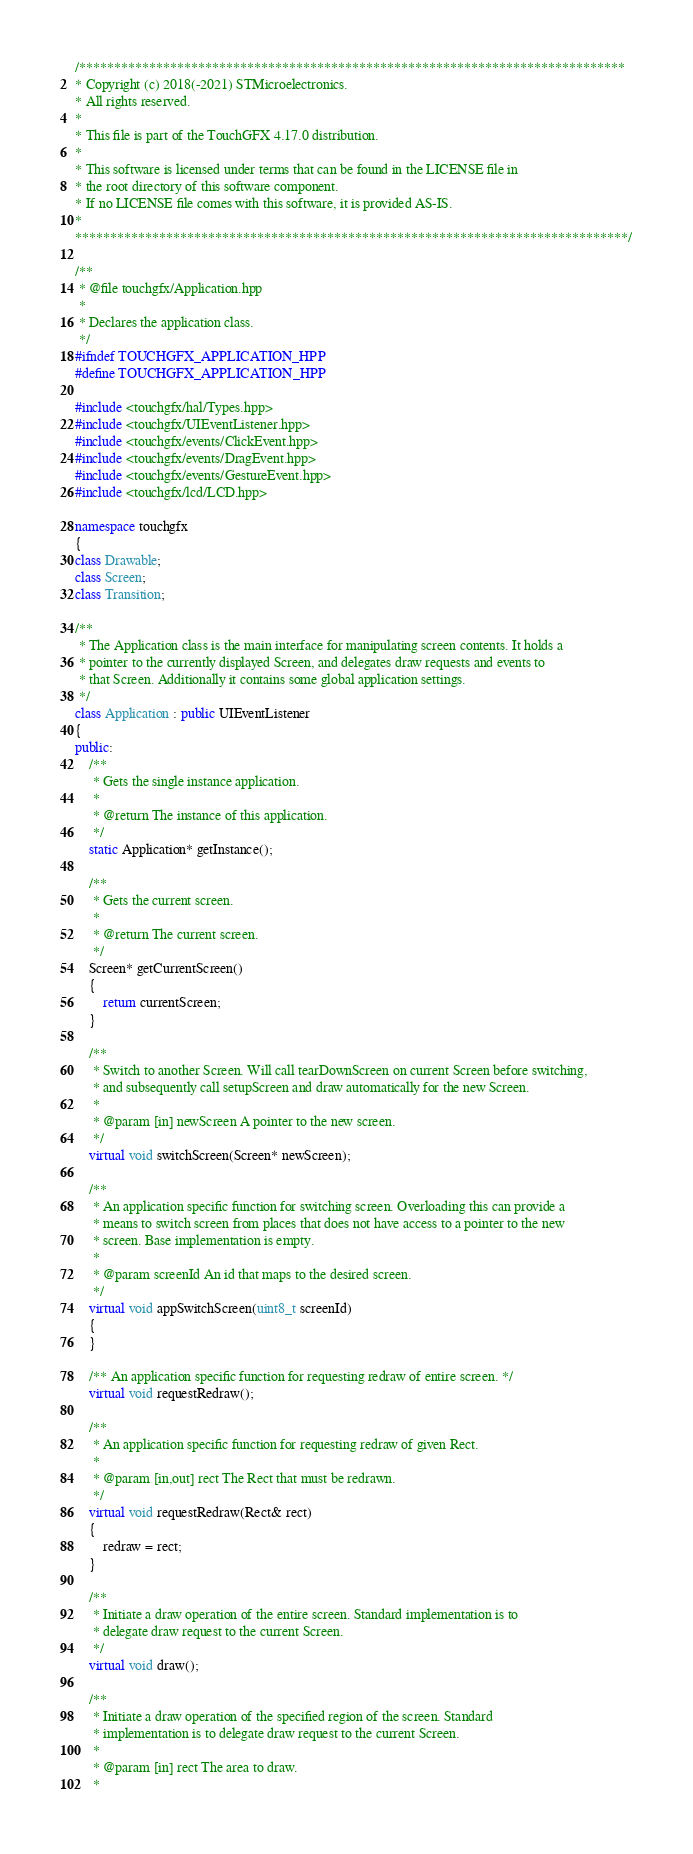<code> <loc_0><loc_0><loc_500><loc_500><_C++_>/******************************************************************************
* Copyright (c) 2018(-2021) STMicroelectronics.
* All rights reserved.
*
* This file is part of the TouchGFX 4.17.0 distribution.
*
* This software is licensed under terms that can be found in the LICENSE file in
* the root directory of this software component.
* If no LICENSE file comes with this software, it is provided AS-IS.
*
*******************************************************************************/

/**
 * @file touchgfx/Application.hpp
 *
 * Declares the application class.
 */
#ifndef TOUCHGFX_APPLICATION_HPP
#define TOUCHGFX_APPLICATION_HPP

#include <touchgfx/hal/Types.hpp>
#include <touchgfx/UIEventListener.hpp>
#include <touchgfx/events/ClickEvent.hpp>
#include <touchgfx/events/DragEvent.hpp>
#include <touchgfx/events/GestureEvent.hpp>
#include <touchgfx/lcd/LCD.hpp>

namespace touchgfx
{
class Drawable;
class Screen;
class Transition;

/**
 * The Application class is the main interface for manipulating screen contents. It holds a
 * pointer to the currently displayed Screen, and delegates draw requests and events to
 * that Screen. Additionally it contains some global application settings.
 */
class Application : public UIEventListener
{
public:
    /**
     * Gets the single instance application.
     *
     * @return The instance of this application.
     */
    static Application* getInstance();

    /**
     * Gets the current screen.
     *
     * @return The current screen.
     */
    Screen* getCurrentScreen()
    {
        return currentScreen;
    }

    /**
     * Switch to another Screen. Will call tearDownScreen on current Screen before switching,
     * and subsequently call setupScreen and draw automatically for the new Screen.
     *
     * @param [in] newScreen A pointer to the new screen.
     */
    virtual void switchScreen(Screen* newScreen);

    /**
     * An application specific function for switching screen. Overloading this can provide a
     * means to switch screen from places that does not have access to a pointer to the new
     * screen. Base implementation is empty.
     *
     * @param screenId An id that maps to the desired screen.
     */
    virtual void appSwitchScreen(uint8_t screenId)
    {
    }

    /** An application specific function for requesting redraw of entire screen. */
    virtual void requestRedraw();

    /**
     * An application specific function for requesting redraw of given Rect.
     *
     * @param [in,out] rect The Rect that must be redrawn.
     */
    virtual void requestRedraw(Rect& rect)
    {
        redraw = rect;
    }

    /**
     * Initiate a draw operation of the entire screen. Standard implementation is to
     * delegate draw request to the current Screen.
     */
    virtual void draw();

    /**
     * Initiate a draw operation of the specified region of the screen. Standard
     * implementation is to delegate draw request to the current Screen.
     *
     * @param [in] rect The area to draw.
     *</code> 